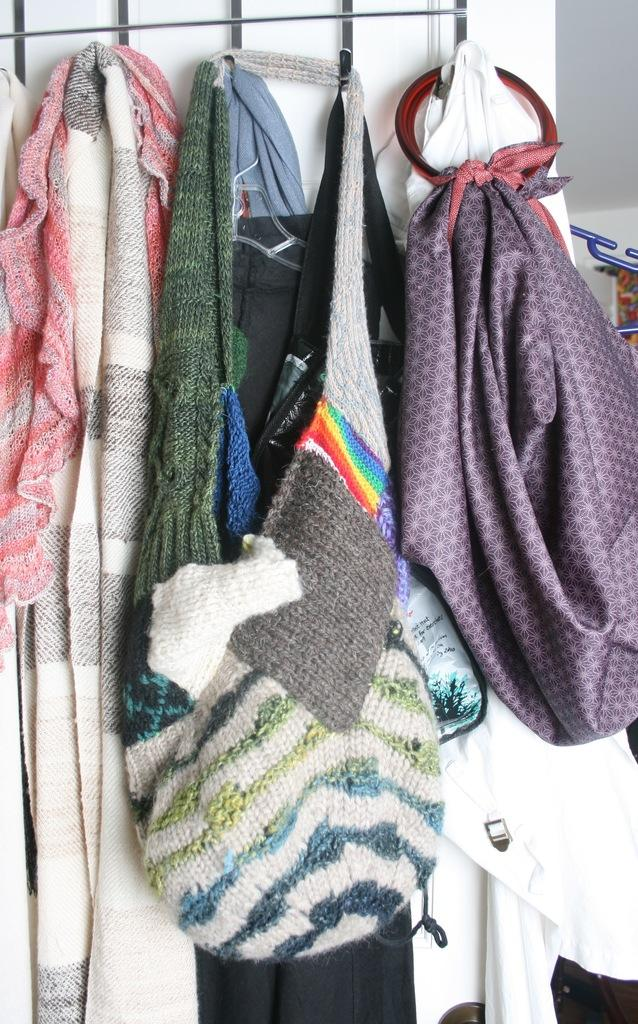What is hanging in the image? There are clothes hanging on a clothes hanger in the image. What can be seen in the background of the image? There is a wall visible in the background of the image. Where is the uncle hiding with the popcorn in the image? There is no uncle or popcorn present in the image. 